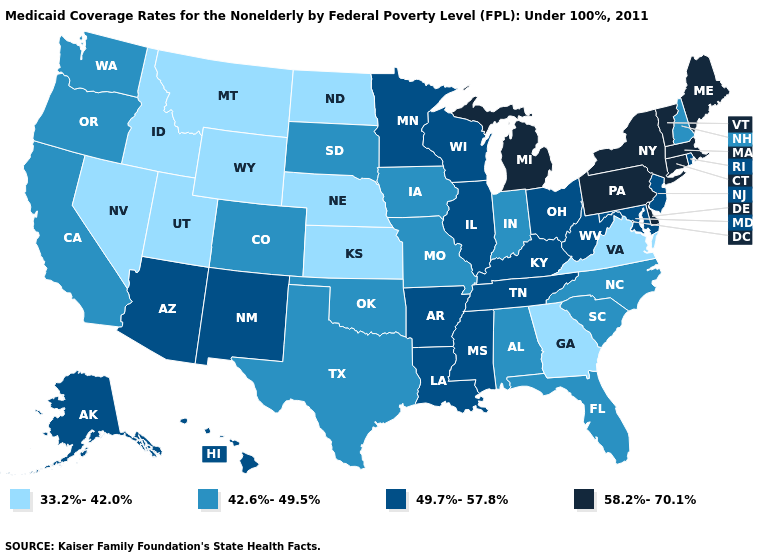What is the value of Rhode Island?
Keep it brief. 49.7%-57.8%. Among the states that border Delaware , which have the lowest value?
Quick response, please. Maryland, New Jersey. What is the lowest value in states that border North Carolina?
Quick response, please. 33.2%-42.0%. Does Pennsylvania have a lower value than Arkansas?
Give a very brief answer. No. What is the value of New York?
Write a very short answer. 58.2%-70.1%. What is the value of Tennessee?
Concise answer only. 49.7%-57.8%. Does New Mexico have the highest value in the West?
Give a very brief answer. Yes. What is the lowest value in the USA?
Concise answer only. 33.2%-42.0%. What is the highest value in the South ?
Give a very brief answer. 58.2%-70.1%. Among the states that border Alabama , which have the highest value?
Give a very brief answer. Mississippi, Tennessee. How many symbols are there in the legend?
Concise answer only. 4. Name the states that have a value in the range 33.2%-42.0%?
Be succinct. Georgia, Idaho, Kansas, Montana, Nebraska, Nevada, North Dakota, Utah, Virginia, Wyoming. Name the states that have a value in the range 42.6%-49.5%?
Give a very brief answer. Alabama, California, Colorado, Florida, Indiana, Iowa, Missouri, New Hampshire, North Carolina, Oklahoma, Oregon, South Carolina, South Dakota, Texas, Washington. Name the states that have a value in the range 49.7%-57.8%?
Give a very brief answer. Alaska, Arizona, Arkansas, Hawaii, Illinois, Kentucky, Louisiana, Maryland, Minnesota, Mississippi, New Jersey, New Mexico, Ohio, Rhode Island, Tennessee, West Virginia, Wisconsin. 